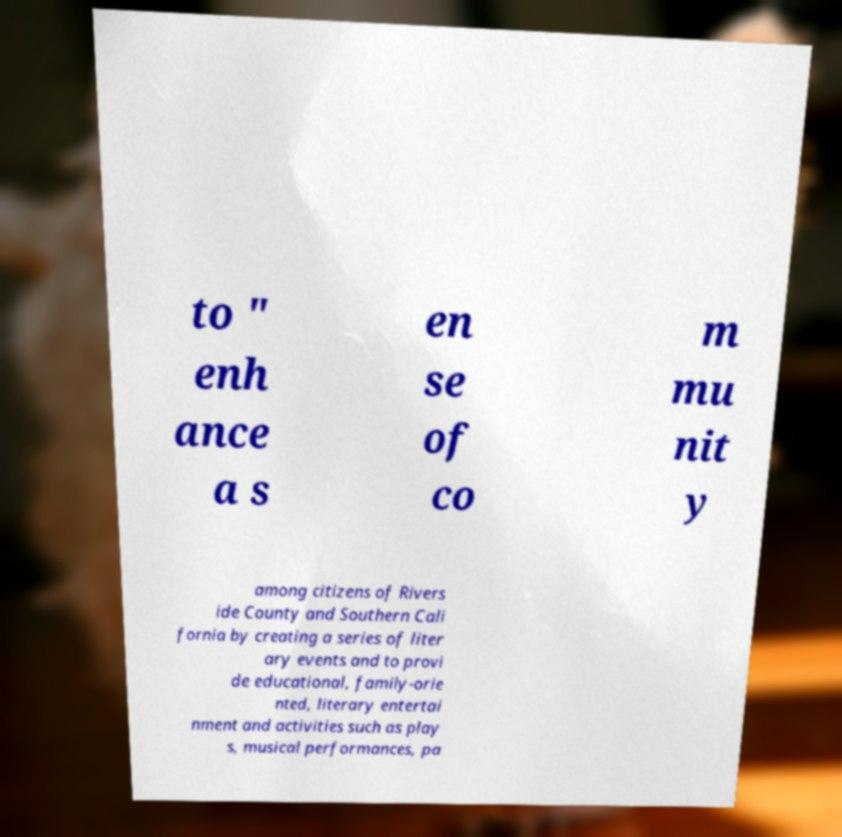Please identify and transcribe the text found in this image. to " enh ance a s en se of co m mu nit y among citizens of Rivers ide County and Southern Cali fornia by creating a series of liter ary events and to provi de educational, family-orie nted, literary entertai nment and activities such as play s, musical performances, pa 